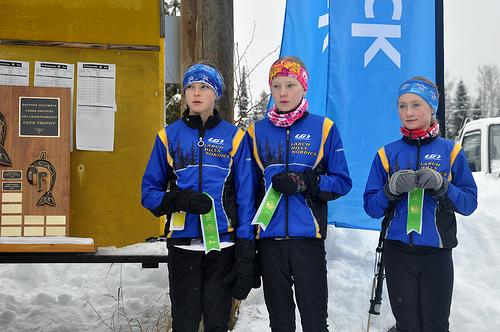What are the girls in the image holding to signify their achievement? Green award ribbons. Briefly describe the location where this image is set. The image is set in a snowy mountain area, where the girls are skiing. List three accessories or clothing items that the girls in the image are wearing. Headbands, ski jackets, and dark pants. What is the most prominent color of the jackets that the girls are wearing in the image? Blue with yellow trim is the most prominent color of the jackets. What sentiment or emotion is being portrayed by the image's subjects? The sentiment portrayed is of joy, success, and camaraderie among the girls. Mention one comment about the girls that implies they share a close bond. The girls are all good friends. What suggests that the girls in the image go to the same school? They are part of a ski team which presumably belongs to their school. How many diverse color bandannas and headbands are explicitly mentioned in the image? Three diverse colors - blue, pink, and orange. Mention two types of headwear that the girls are wearing in the image. Blue bandanna and pink headband. Identify the main activity taking place in the image. A group of young girls skiing and celebrating their victory with green award ribbons. 